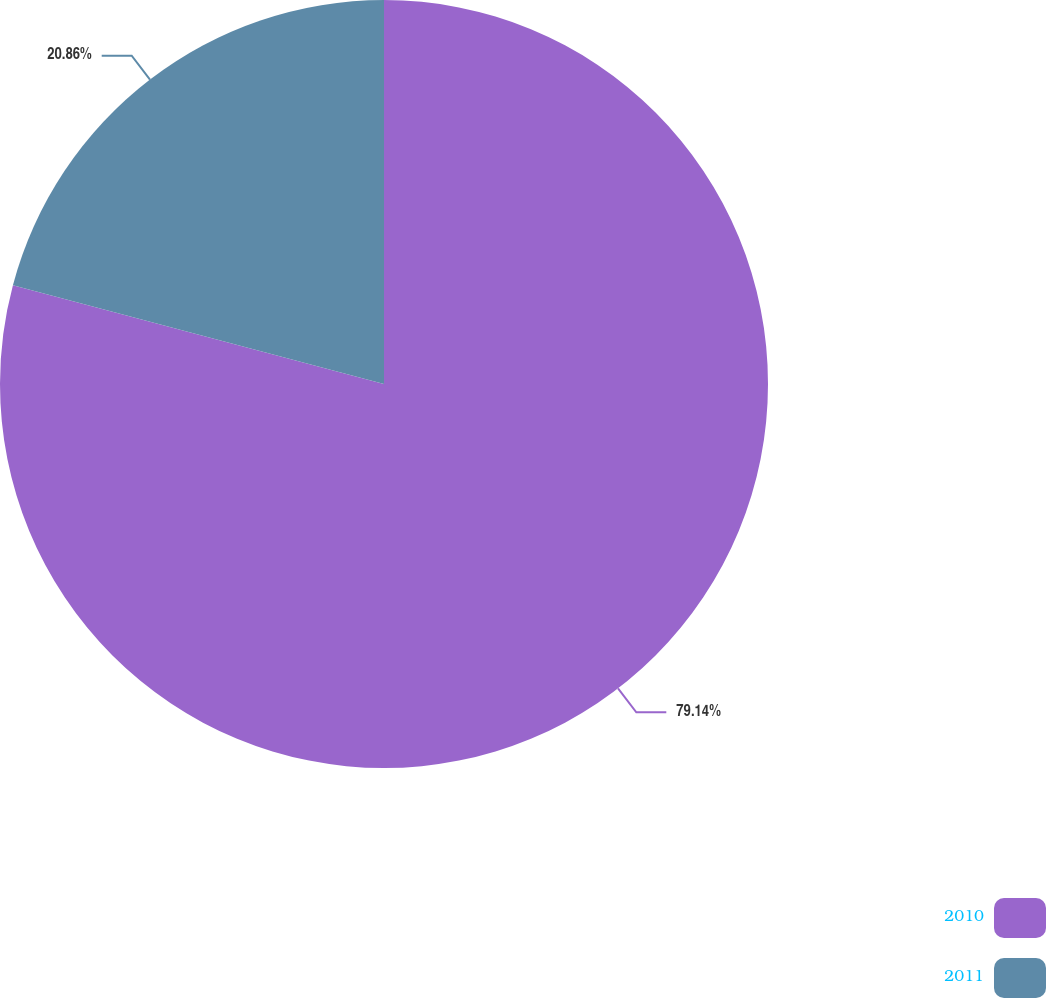Convert chart to OTSL. <chart><loc_0><loc_0><loc_500><loc_500><pie_chart><fcel>2010<fcel>2011<nl><fcel>79.14%<fcel>20.86%<nl></chart> 